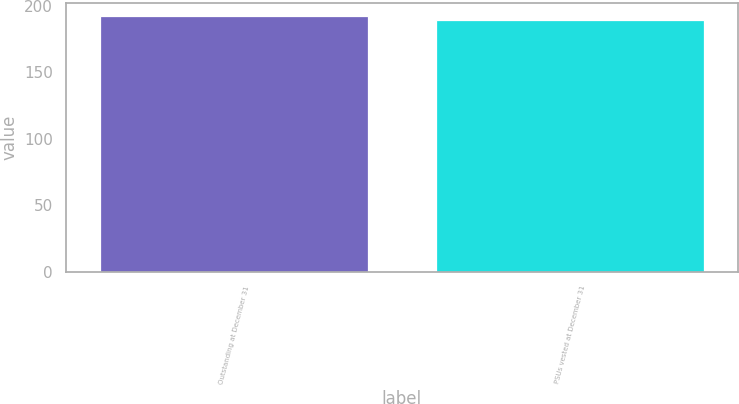<chart> <loc_0><loc_0><loc_500><loc_500><bar_chart><fcel>Outstanding at December 31<fcel>PSUs vested at December 31<nl><fcel>192<fcel>189<nl></chart> 